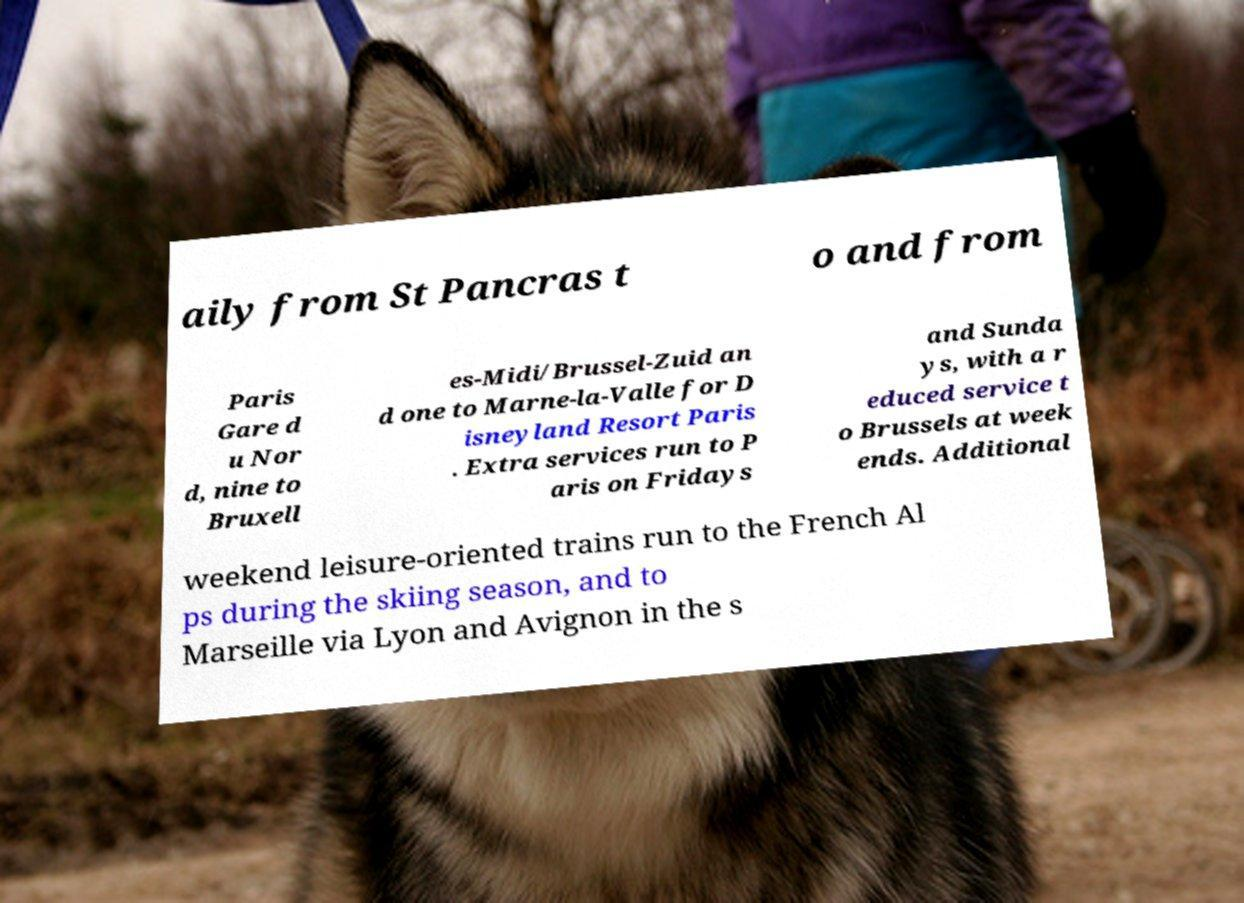I need the written content from this picture converted into text. Can you do that? aily from St Pancras t o and from Paris Gare d u Nor d, nine to Bruxell es-Midi/Brussel-Zuid an d one to Marne-la-Valle for D isneyland Resort Paris . Extra services run to P aris on Fridays and Sunda ys, with a r educed service t o Brussels at week ends. Additional weekend leisure-oriented trains run to the French Al ps during the skiing season, and to Marseille via Lyon and Avignon in the s 